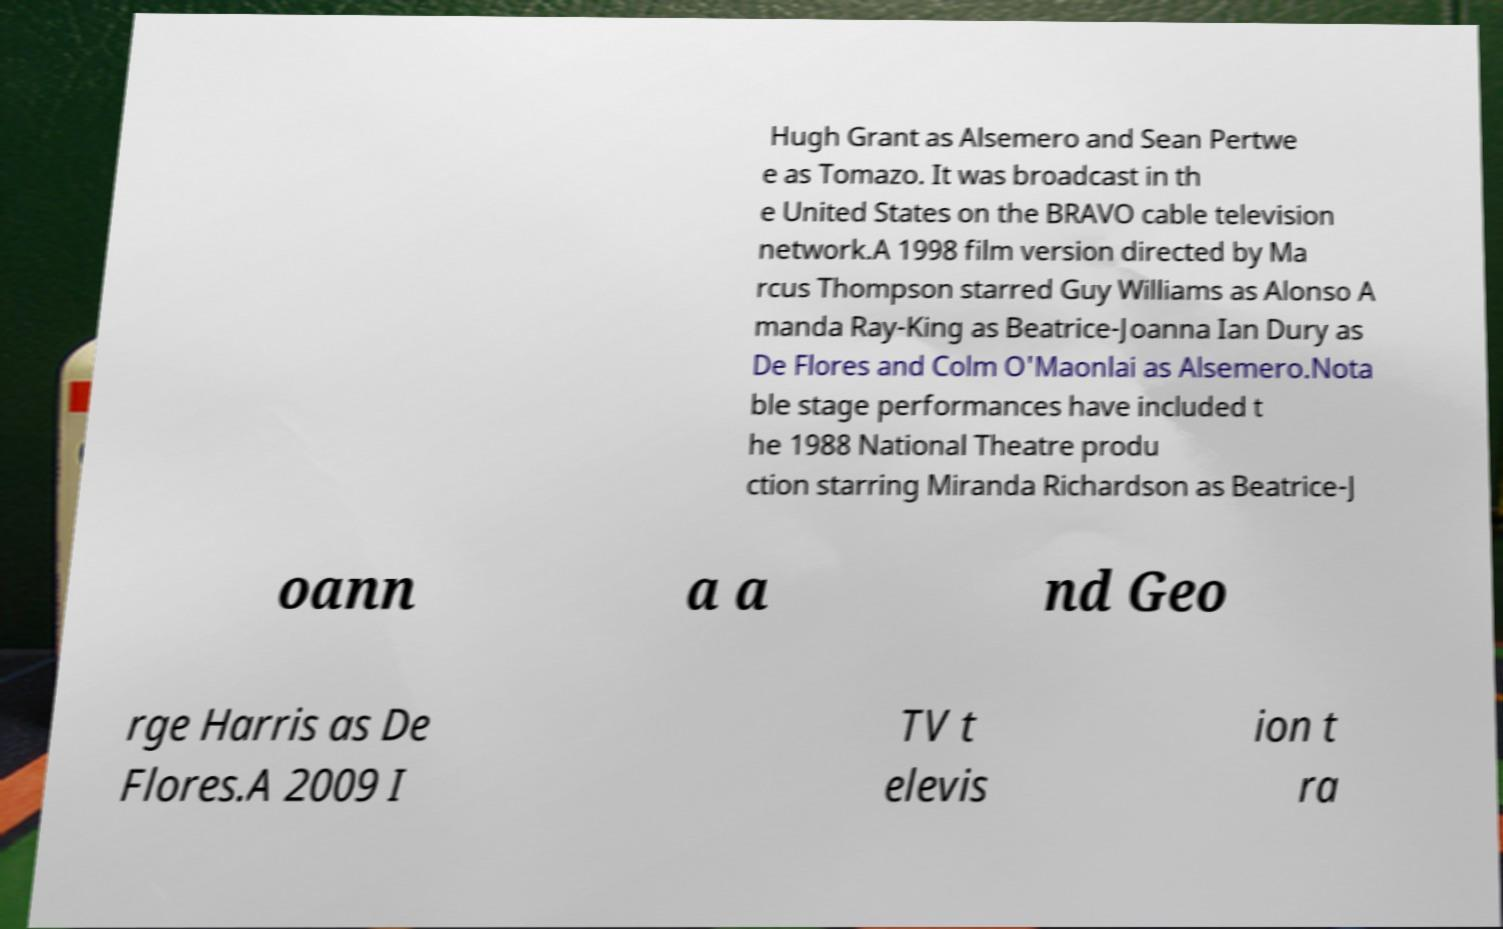Please identify and transcribe the text found in this image. Hugh Grant as Alsemero and Sean Pertwe e as Tomazo. It was broadcast in th e United States on the BRAVO cable television network.A 1998 film version directed by Ma rcus Thompson starred Guy Williams as Alonso A manda Ray-King as Beatrice-Joanna Ian Dury as De Flores and Colm O'Maonlai as Alsemero.Nota ble stage performances have included t he 1988 National Theatre produ ction starring Miranda Richardson as Beatrice-J oann a a nd Geo rge Harris as De Flores.A 2009 I TV t elevis ion t ra 